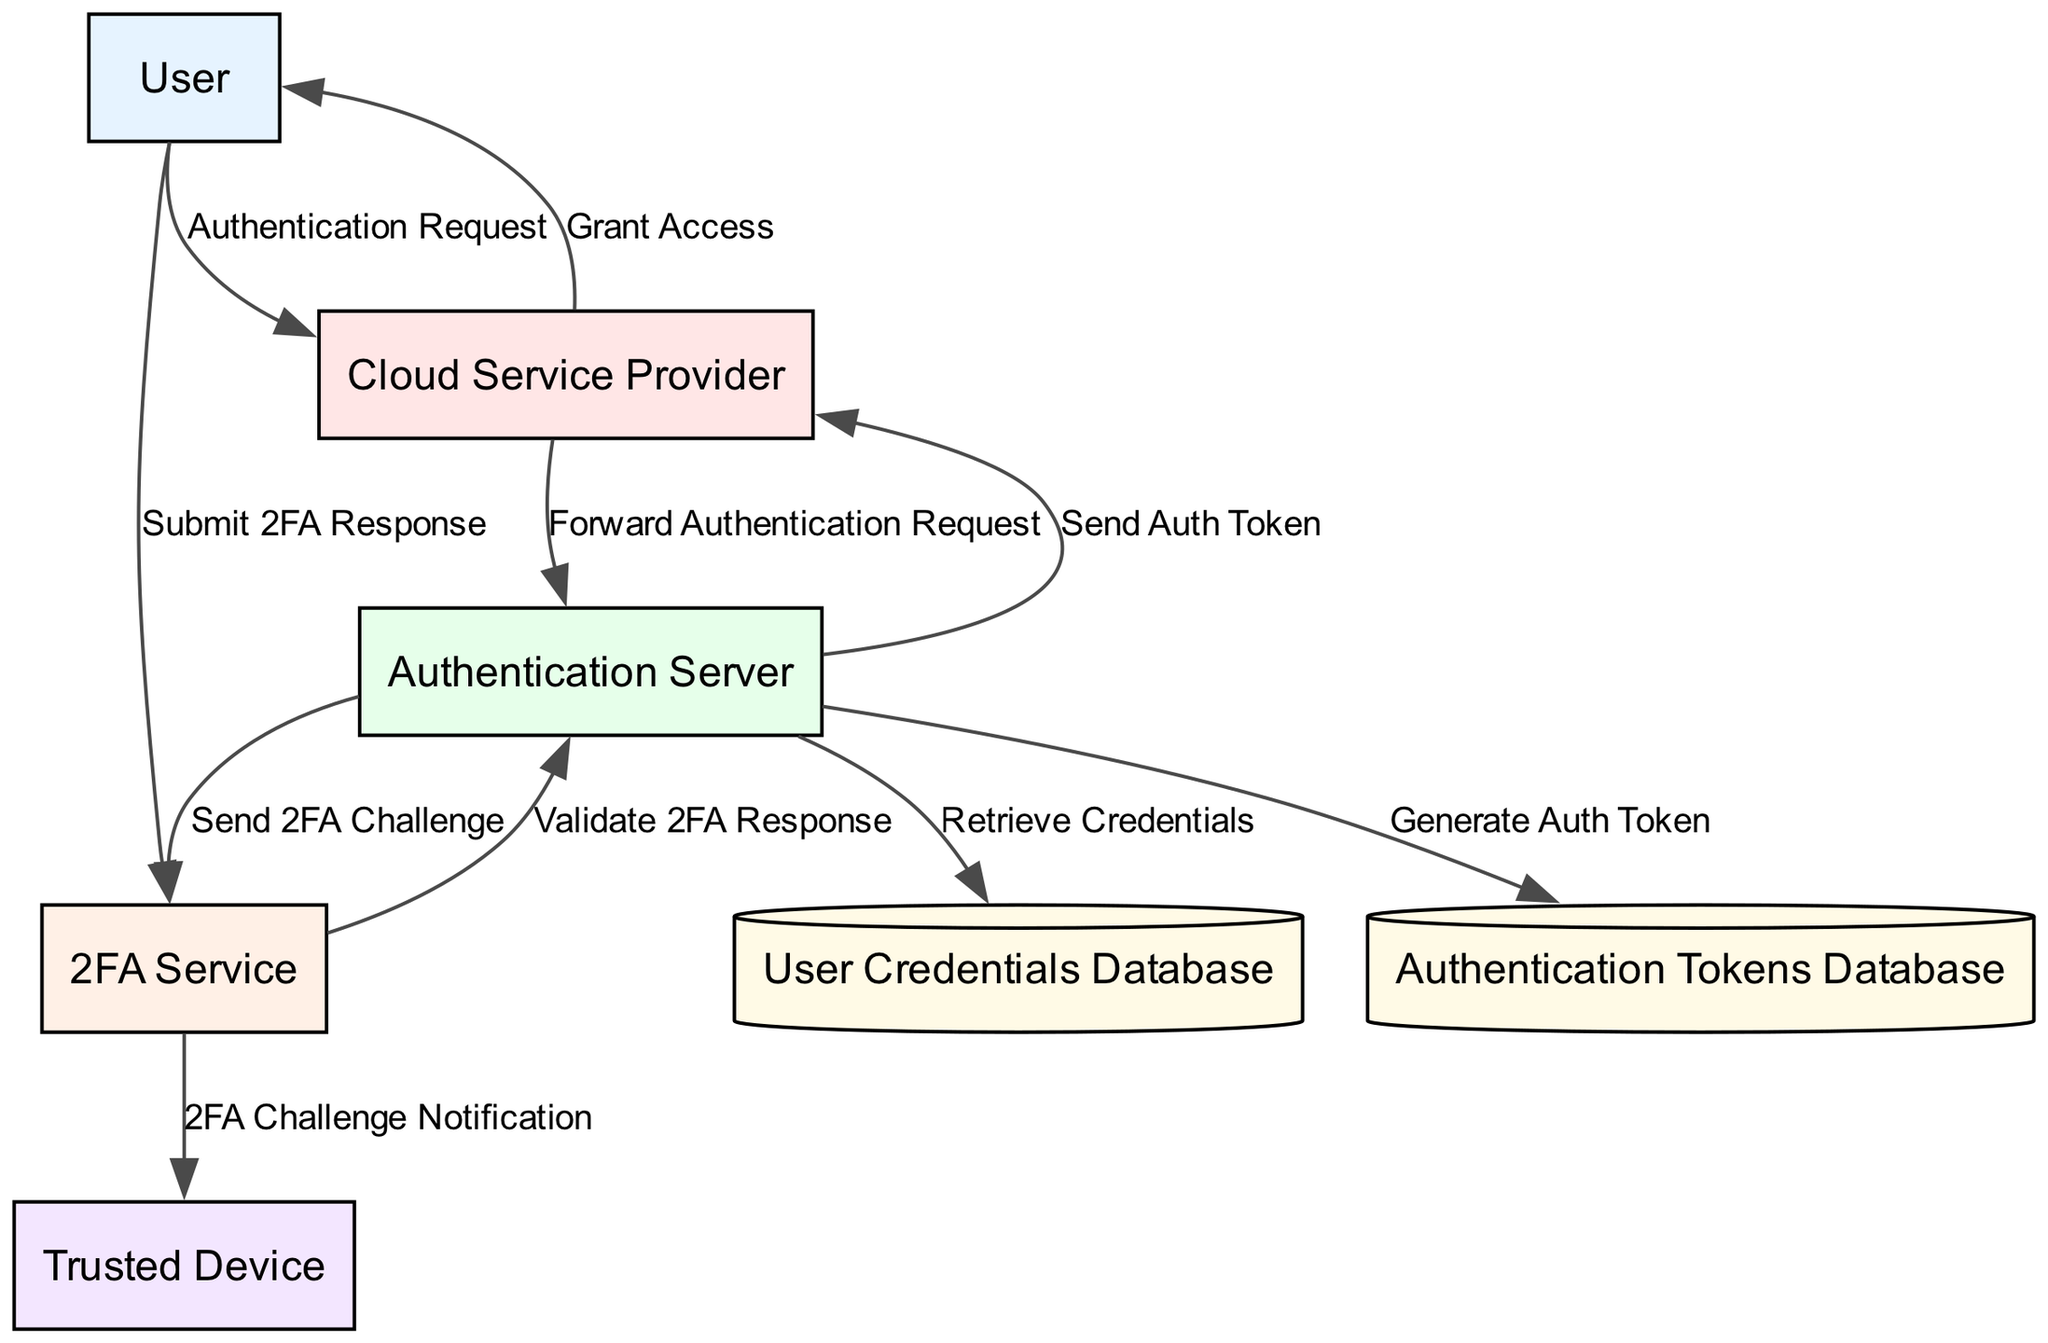What is the name of the entity that verifies user credentials? The entity responsible for verifying user credentials in the diagram is labeled as "Authentication Server." This can be found in the section of entities listed in the diagram.
Answer: Authentication Server How many data stores are present in the diagram? The diagram includes two data stores: "User Credentials Database" and "Authentication Tokens Database." Counting these gives a total of two.
Answer: 2 Which entity sends the 2FA challenge to the trusted device? The "2FA Service" is the entity that sends the 2FA challenge notification to the "Trusted Device." The flow can be traced from the 2FA Service to the Trusted Device.
Answer: 2FA Service What does the User submit to the 2FA Service? According to the data flow, the user submits the "2FA Response" to the 2FA service. The data is labeled clearly in the flow from the User to the 2FA Service.
Answer: 2FA Response What is the final action taken by the Cloud Service Provider? The final action taken by the Cloud Service Provider, as indicated in the flow, is to "Grant Access" to the User based on the provided authentication token. This step is the last in the sequence of flows in the diagram.
Answer: Grant Access What request does the user send to access cloud services? The initial action taken by the User is an "Authentication Request" sent to the Cloud Service Provider. This is the first step in the process outlined in the diagram.
Answer: Authentication Request Which database is responsible for storing user credentials and 2FA configuration? The database that stores user credentials and 2FA configuration is labeled as the "User Credentials Database." This is indicated in the section of data stores in the diagram.
Answer: User Credentials Database Which service validates the 2FA response? The service responsible for validating the 2FA response is the "2FA Service." The interaction can be traced from the 2FA Service to the Authentication Server in the flow of the diagram.
Answer: 2FA Service 